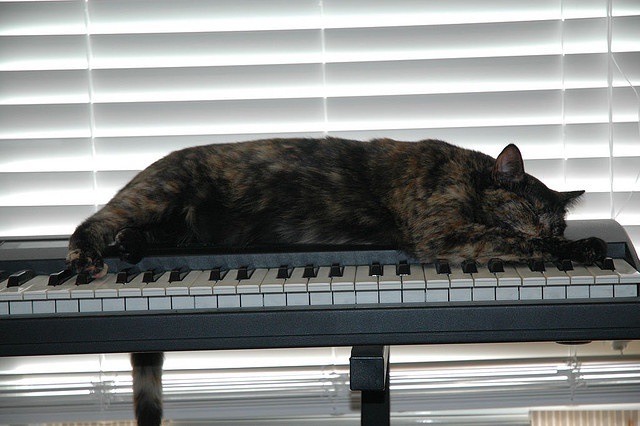Describe the objects in this image and their specific colors. I can see a cat in white, black, and gray tones in this image. 